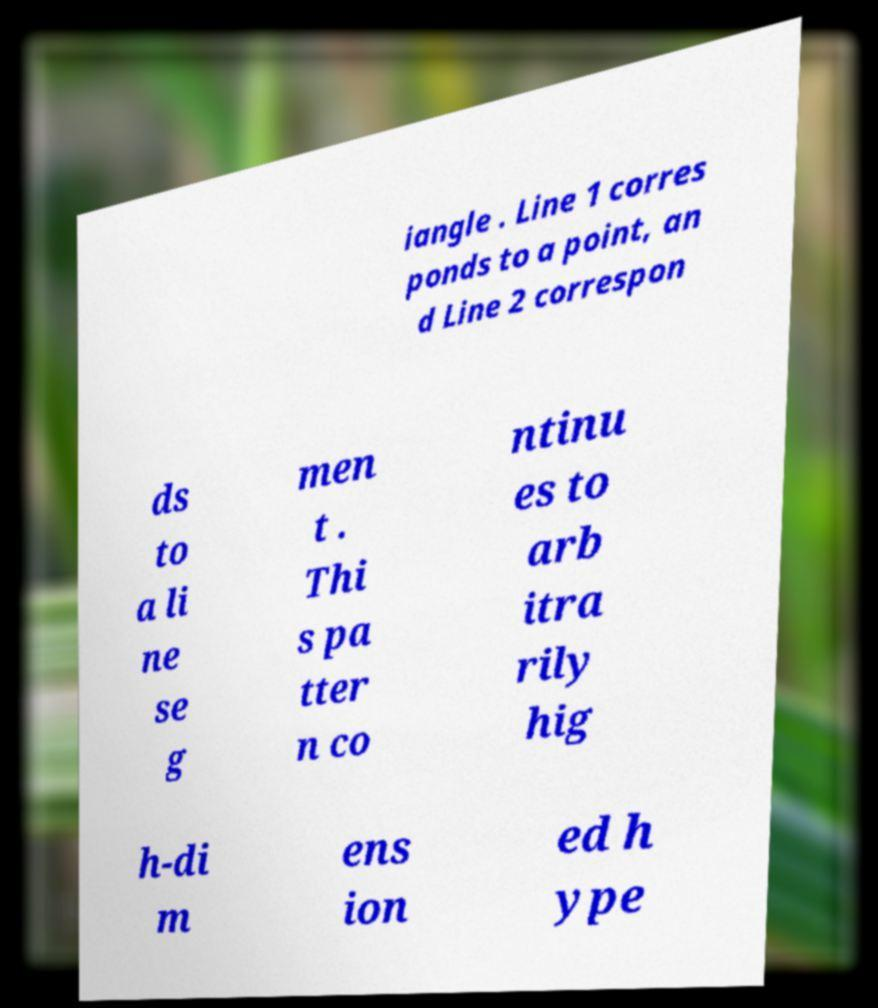Could you extract and type out the text from this image? iangle . Line 1 corres ponds to a point, an d Line 2 correspon ds to a li ne se g men t . Thi s pa tter n co ntinu es to arb itra rily hig h-di m ens ion ed h ype 